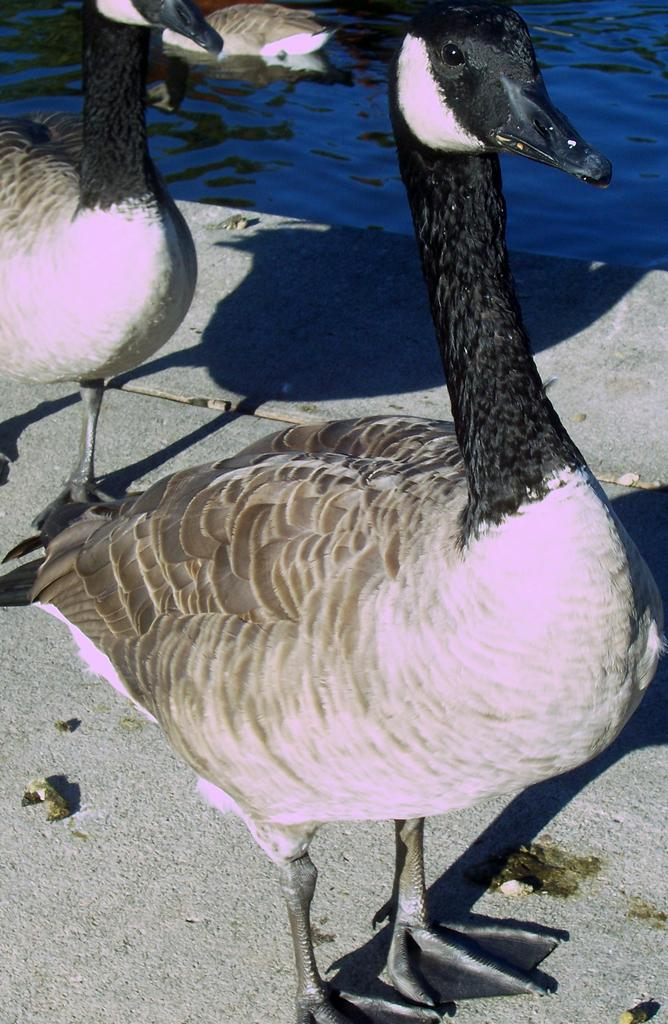How many birds can be seen in the image? There are two birds in the image. Where are the birds located in the image? The birds are on the surface of something in the image. What is the surface that the birds are on? The surface appears to be water. What else can be seen in the image besides the birds? There is water visible at the top of the image. What type of tax is being discussed in the image? There is no discussion of tax in the image; it features two birds on a water surface. 